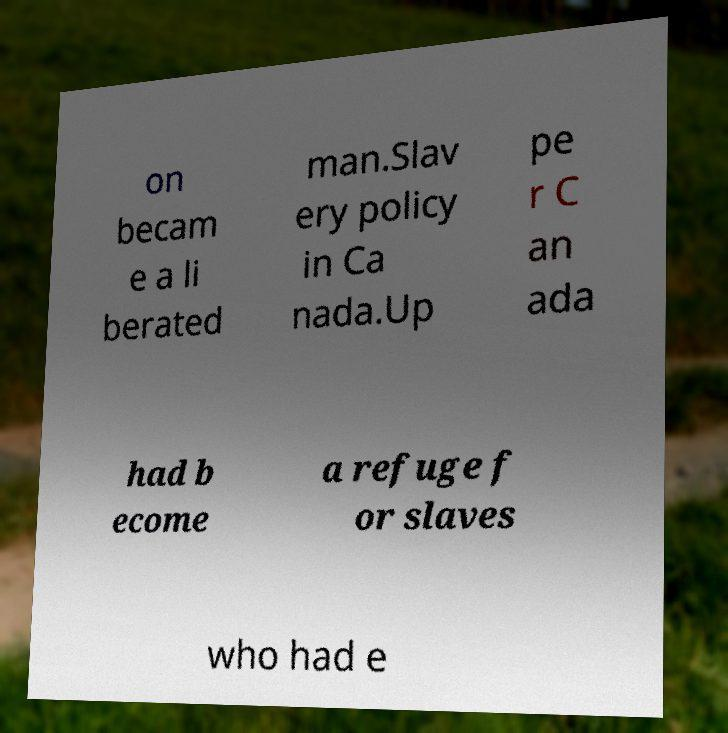I need the written content from this picture converted into text. Can you do that? on becam e a li berated man.Slav ery policy in Ca nada.Up pe r C an ada had b ecome a refuge f or slaves who had e 